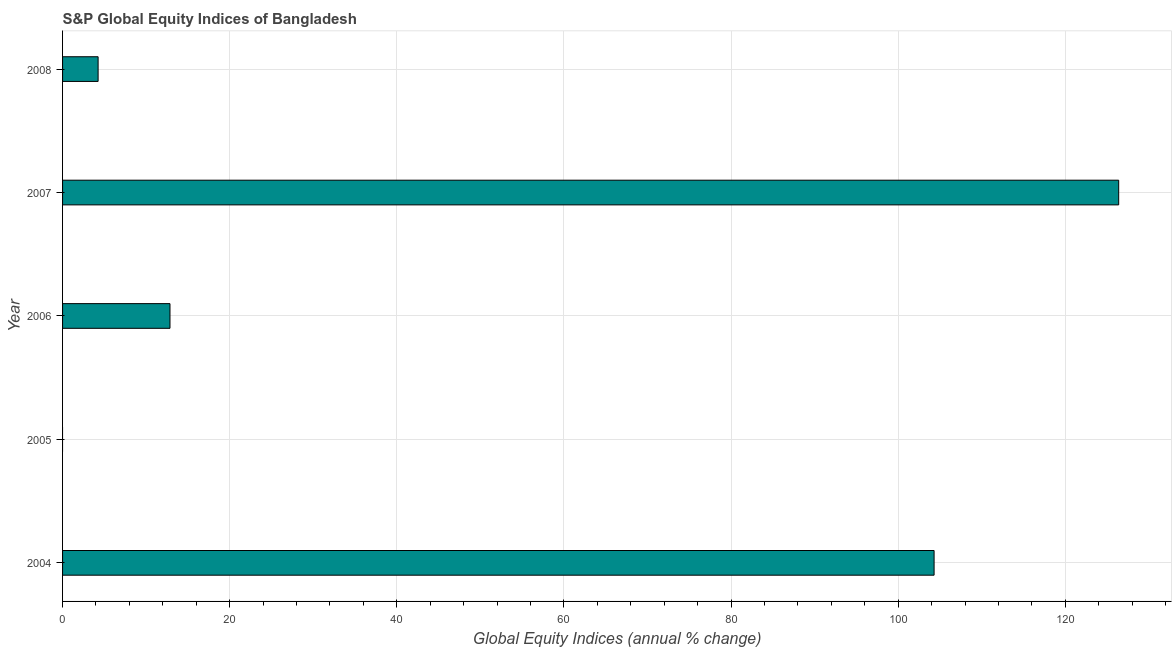Does the graph contain any zero values?
Offer a terse response. Yes. What is the title of the graph?
Your answer should be very brief. S&P Global Equity Indices of Bangladesh. What is the label or title of the X-axis?
Give a very brief answer. Global Equity Indices (annual % change). What is the label or title of the Y-axis?
Make the answer very short. Year. What is the s&p global equity indices in 2007?
Ensure brevity in your answer.  126.39. Across all years, what is the maximum s&p global equity indices?
Give a very brief answer. 126.39. Across all years, what is the minimum s&p global equity indices?
Your response must be concise. 0. In which year was the s&p global equity indices maximum?
Ensure brevity in your answer.  2007. What is the sum of the s&p global equity indices?
Provide a short and direct response. 247.8. What is the difference between the s&p global equity indices in 2004 and 2006?
Keep it short and to the point. 91.44. What is the average s&p global equity indices per year?
Your response must be concise. 49.56. What is the median s&p global equity indices?
Your response must be concise. 12.86. What is the ratio of the s&p global equity indices in 2004 to that in 2006?
Ensure brevity in your answer.  8.11. What is the difference between the highest and the second highest s&p global equity indices?
Offer a very short reply. 22.09. What is the difference between the highest and the lowest s&p global equity indices?
Offer a terse response. 126.39. In how many years, is the s&p global equity indices greater than the average s&p global equity indices taken over all years?
Provide a succinct answer. 2. How many bars are there?
Provide a short and direct response. 4. Are all the bars in the graph horizontal?
Offer a terse response. Yes. How many years are there in the graph?
Provide a succinct answer. 5. Are the values on the major ticks of X-axis written in scientific E-notation?
Offer a very short reply. No. What is the Global Equity Indices (annual % change) of 2004?
Make the answer very short. 104.3. What is the Global Equity Indices (annual % change) of 2006?
Keep it short and to the point. 12.86. What is the Global Equity Indices (annual % change) of 2007?
Give a very brief answer. 126.39. What is the Global Equity Indices (annual % change) of 2008?
Keep it short and to the point. 4.25. What is the difference between the Global Equity Indices (annual % change) in 2004 and 2006?
Your response must be concise. 91.44. What is the difference between the Global Equity Indices (annual % change) in 2004 and 2007?
Provide a succinct answer. -22.09. What is the difference between the Global Equity Indices (annual % change) in 2004 and 2008?
Your answer should be very brief. 100.05. What is the difference between the Global Equity Indices (annual % change) in 2006 and 2007?
Ensure brevity in your answer.  -113.54. What is the difference between the Global Equity Indices (annual % change) in 2006 and 2008?
Give a very brief answer. 8.6. What is the difference between the Global Equity Indices (annual % change) in 2007 and 2008?
Your answer should be very brief. 122.14. What is the ratio of the Global Equity Indices (annual % change) in 2004 to that in 2006?
Give a very brief answer. 8.11. What is the ratio of the Global Equity Indices (annual % change) in 2004 to that in 2007?
Your answer should be very brief. 0.82. What is the ratio of the Global Equity Indices (annual % change) in 2004 to that in 2008?
Keep it short and to the point. 24.52. What is the ratio of the Global Equity Indices (annual % change) in 2006 to that in 2007?
Ensure brevity in your answer.  0.1. What is the ratio of the Global Equity Indices (annual % change) in 2006 to that in 2008?
Make the answer very short. 3.02. What is the ratio of the Global Equity Indices (annual % change) in 2007 to that in 2008?
Your answer should be very brief. 29.71. 